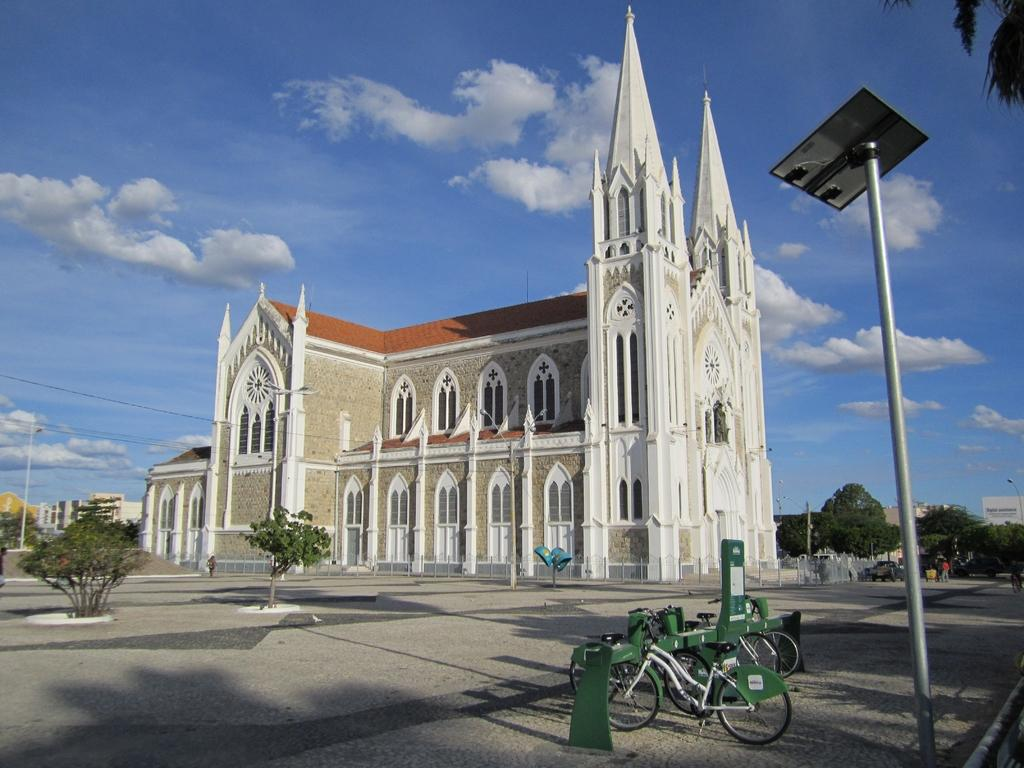What objects are on the right side of the image? There are poles and cycles on the right side of the image. What can be seen in the background of the image? The sky, clouds, trees, buildings, a wall, a roof, windows, a road, and a sign board are visible in the background of the image. Is there any human presence in the image? Yes, there is a person is standing in the background of the image. How many frogs are hopping on the cycles in the image? There are no frogs present in the image, and therefore no frogs are hopping on the cycles. What type of school can be seen in the image? There is no school present in the image. What is the person in the image using to whip the trees? There is no whip or any indication of tree-whipping activity in the image. 